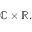<formula> <loc_0><loc_0><loc_500><loc_500>\mathbb { C } \times \mathbb { R } .</formula> 